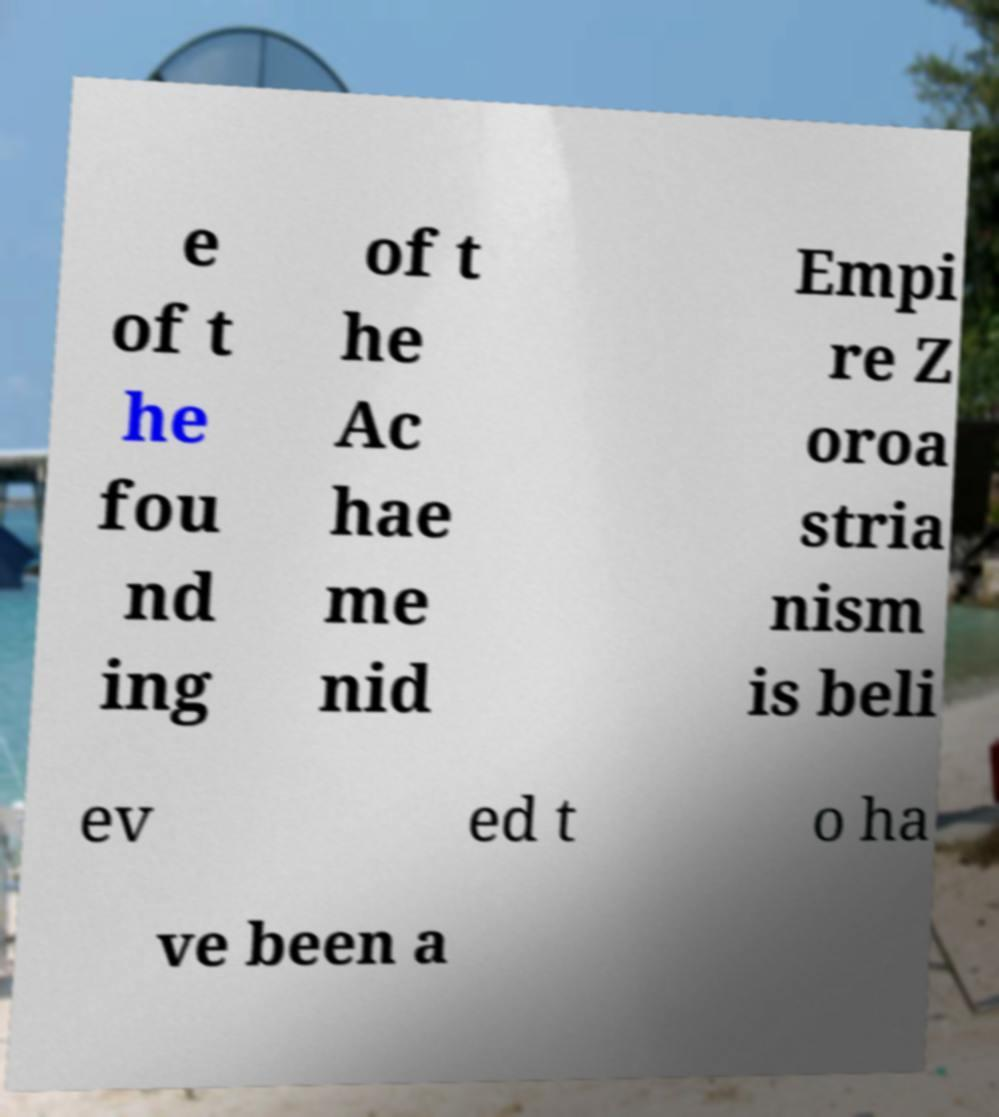Please read and relay the text visible in this image. What does it say? e of t he fou nd ing of t he Ac hae me nid Empi re Z oroa stria nism is beli ev ed t o ha ve been a 